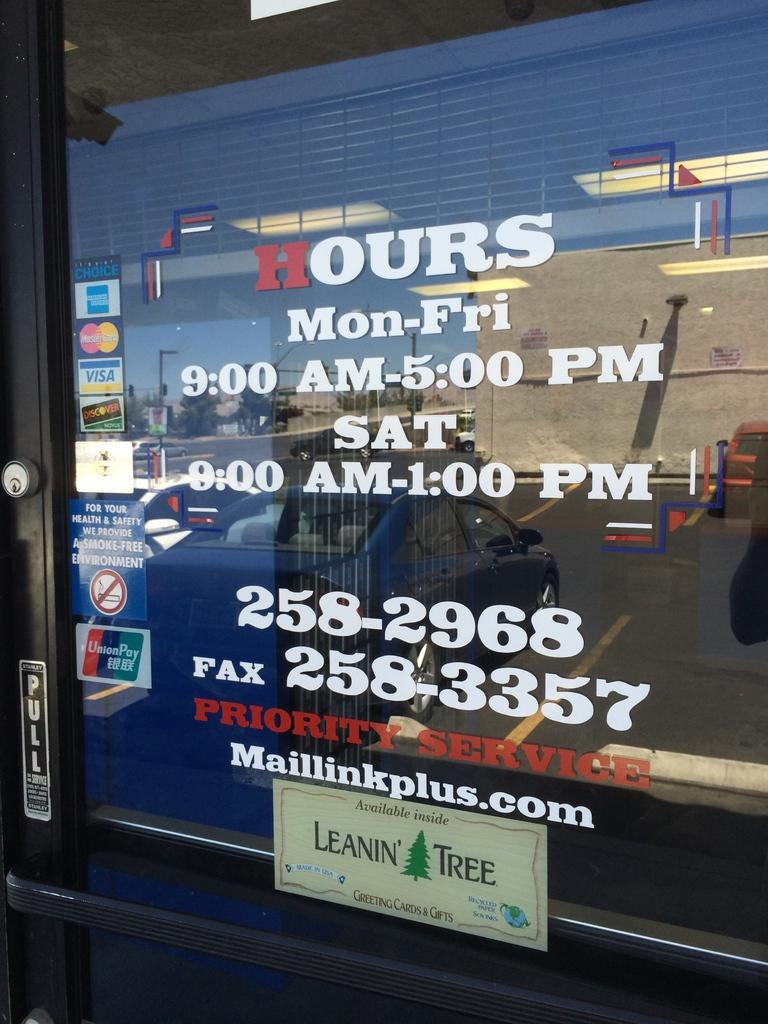What is the main subject of the image? The main subject of the image is a door. Where is the door located in the image? The door is in the center of the image. What can be seen on the door? There is text written on the door. What type of seed is being used as bait on the door in the image? There is no seed or bait present on the door in the image; it only has text written on it. How many mittens are hanging on the door in the image? There are no mittens present on the door in the image. 